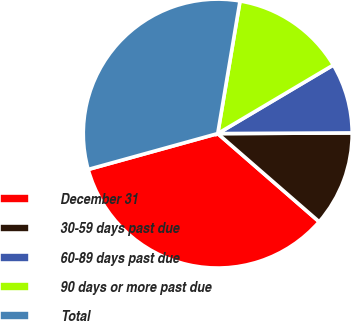Convert chart to OTSL. <chart><loc_0><loc_0><loc_500><loc_500><pie_chart><fcel>December 31<fcel>30-59 days past due<fcel>60-89 days past due<fcel>90 days or more past due<fcel>Total<nl><fcel>34.31%<fcel>11.47%<fcel>8.44%<fcel>13.83%<fcel>31.95%<nl></chart> 